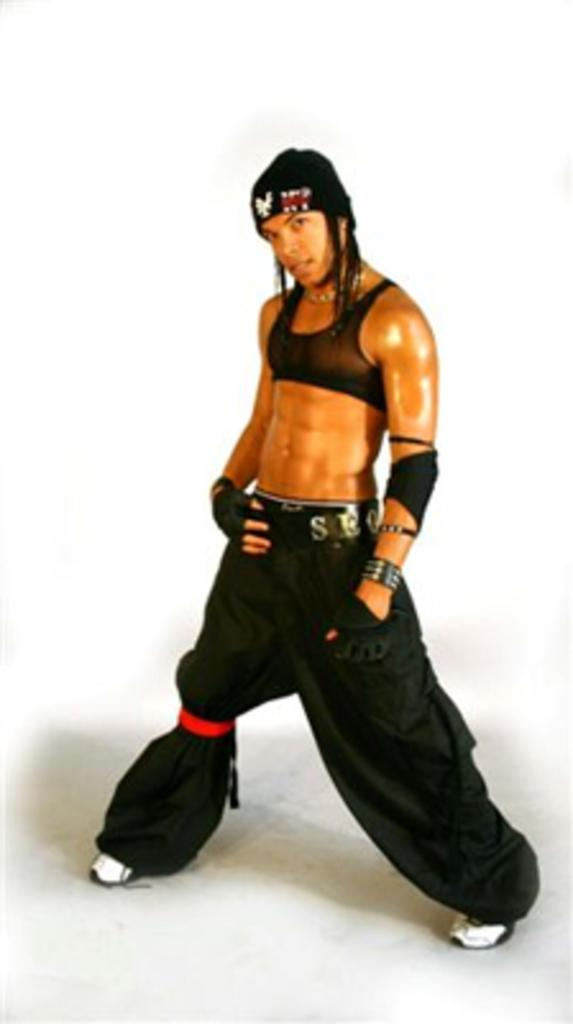What is the main subject of the image? There is a person in the image. What is the person wearing? The person is wearing a black dress, a hat, and shoes. What color is the background of the image? The background of the image is white. What type of land can be seen in the background of the image? There is no land visible in the background of the image; it is a white background. Are there any bushes or plants present in the image? There are no bushes or plants visible in the image; it features a person wearing a black dress, hat, and shoes against a white background. 